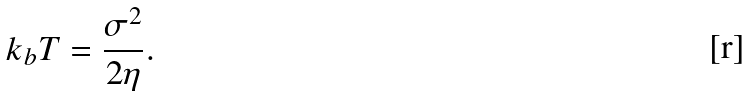<formula> <loc_0><loc_0><loc_500><loc_500>k _ { b } T = \frac { \sigma ^ { 2 } } { 2 \eta } .</formula> 